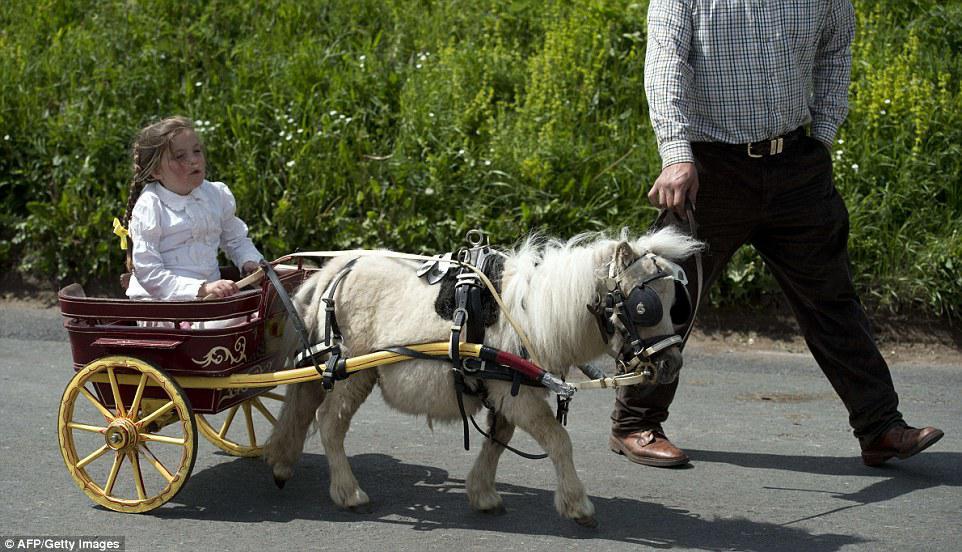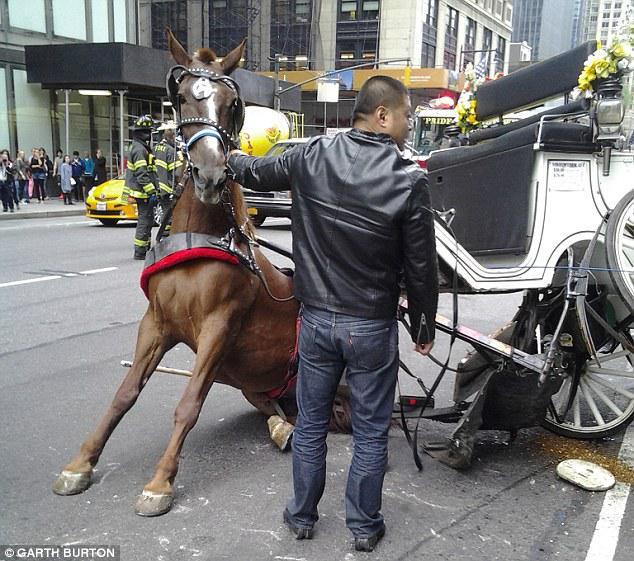The first image is the image on the left, the second image is the image on the right. For the images displayed, is the sentence "In at least one image there are two white horses pulling a white pumpkin carriage." factually correct? Answer yes or no. No. The first image is the image on the left, the second image is the image on the right. Examine the images to the left and right. Is the description "there are white horses with tassels on the top of their heads pulling a cinderella type princess carriage" accurate? Answer yes or no. No. 